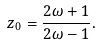Convert formula to latex. <formula><loc_0><loc_0><loc_500><loc_500>z _ { 0 } = \frac { 2 \omega + 1 } { 2 \omega - 1 } .</formula> 